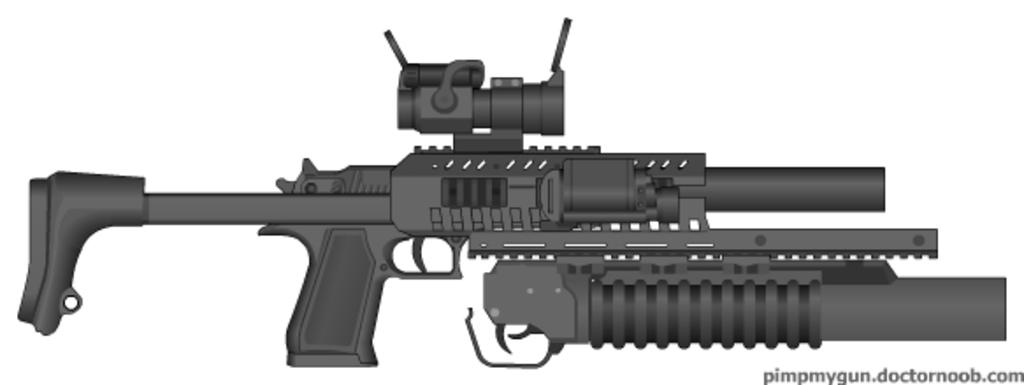What object is the main subject of the image? There is a gun in the image. Can you describe the color of the gun? The gun is black in color. What is the background color of the image? The background of the image is white. Is the stranger reading a book in the image? There is no stranger or book present in the image; it only features a gun. 